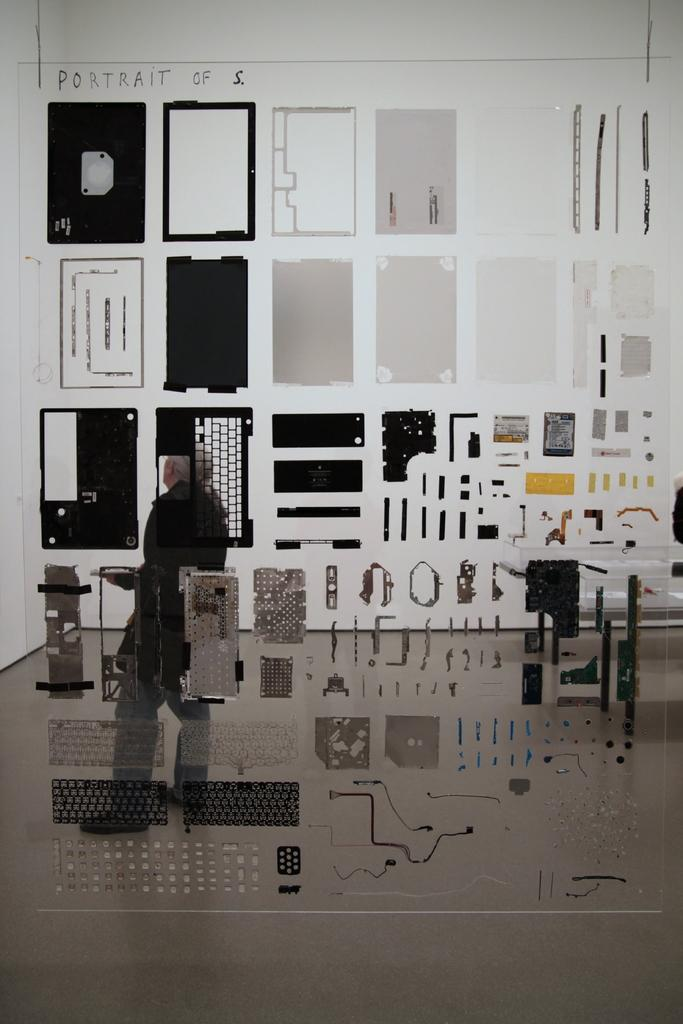What can be seen on the wall in the image? There are things on the wall in the image. Can you describe the person in the image? There is a person standing behind the wall in the image. Where is the text or writing located in the image? The text or writing is on the top left side of the image. What type of pickle is the person holding in the image? There is no pickle present in the image; the person is standing behind the wall. How does the person's temper affect the text on the wall in the image? There is no indication of the person's temper in the image, and the text on the wall is not affected by any emotions. 